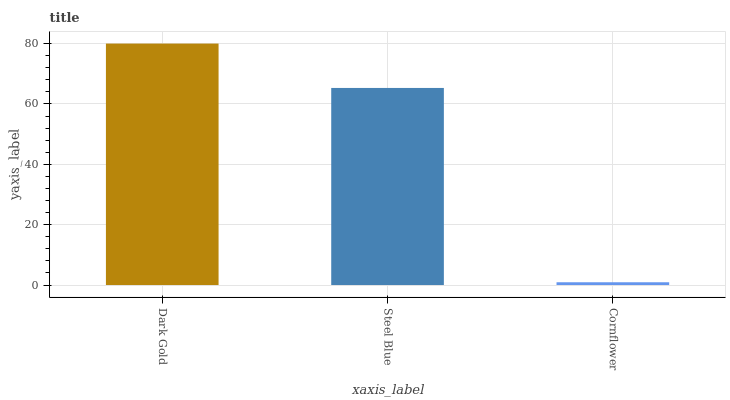Is Cornflower the minimum?
Answer yes or no. Yes. Is Dark Gold the maximum?
Answer yes or no. Yes. Is Steel Blue the minimum?
Answer yes or no. No. Is Steel Blue the maximum?
Answer yes or no. No. Is Dark Gold greater than Steel Blue?
Answer yes or no. Yes. Is Steel Blue less than Dark Gold?
Answer yes or no. Yes. Is Steel Blue greater than Dark Gold?
Answer yes or no. No. Is Dark Gold less than Steel Blue?
Answer yes or no. No. Is Steel Blue the high median?
Answer yes or no. Yes. Is Steel Blue the low median?
Answer yes or no. Yes. Is Cornflower the high median?
Answer yes or no. No. Is Cornflower the low median?
Answer yes or no. No. 